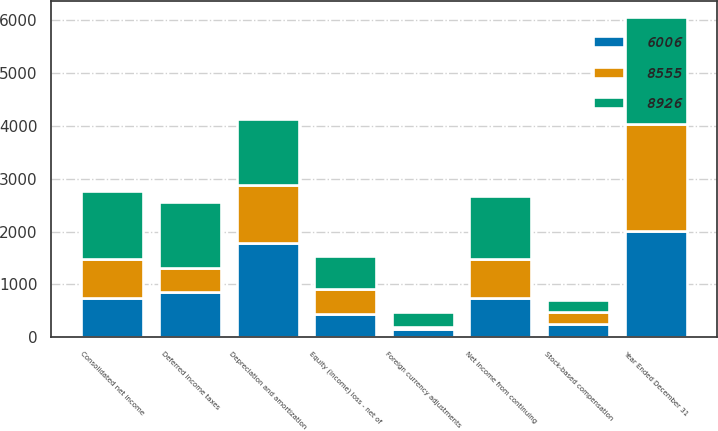<chart> <loc_0><loc_0><loc_500><loc_500><stacked_bar_chart><ecel><fcel>Year Ended December 31<fcel>Consolidated net income<fcel>Net income from continuing<fcel>Depreciation and amortization<fcel>Stock-based compensation<fcel>Deferred income taxes<fcel>Equity (income) loss - net of<fcel>Foreign currency adjustments<nl><fcel>8555<fcel>2018<fcel>742<fcel>742<fcel>1086<fcel>225<fcel>450<fcel>457<fcel>38<nl><fcel>8926<fcel>2017<fcel>1283<fcel>1182<fcel>1260<fcel>219<fcel>1256<fcel>628<fcel>281<nl><fcel>6006<fcel>2016<fcel>742<fcel>742<fcel>1787<fcel>258<fcel>856<fcel>449<fcel>158<nl></chart> 